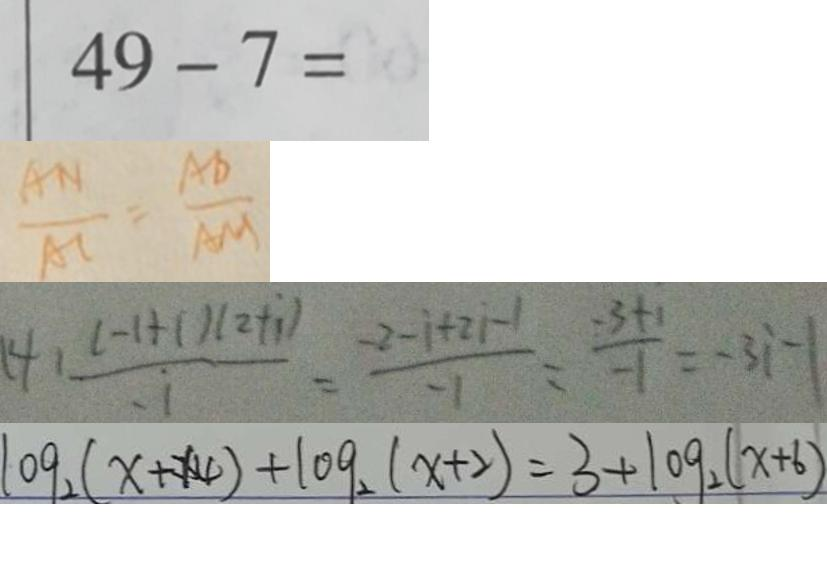<formula> <loc_0><loc_0><loc_500><loc_500>4 9 - 7 = 
 \frac { A N } { A C } = \frac { A D } { A M } 
 ( 4 ) \frac { ( - 1 + i ) ( 2 + i ) } { i } = \frac { - 2 - i + 2 i - 1 } { - 1 } = \frac { - 3 + 1 } { - 1 } = - 3 i - 1 
 \log _ { 2 } ( x + 1 4 ) + \log _ { 2 } ( x + 2 ) = 3 + \log _ { 2 } ( x + 6 )</formula> 